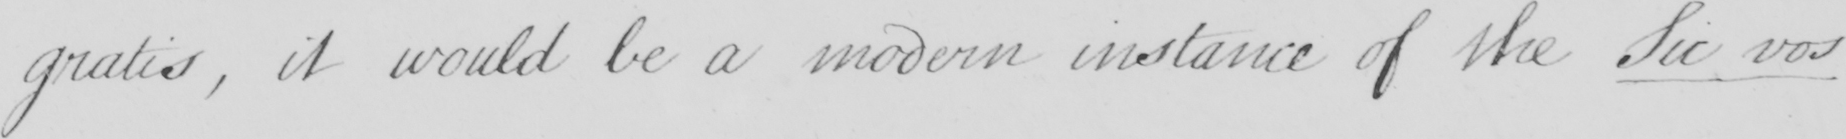What does this handwritten line say? gratis , it would be a modern instance of the Sic vos 